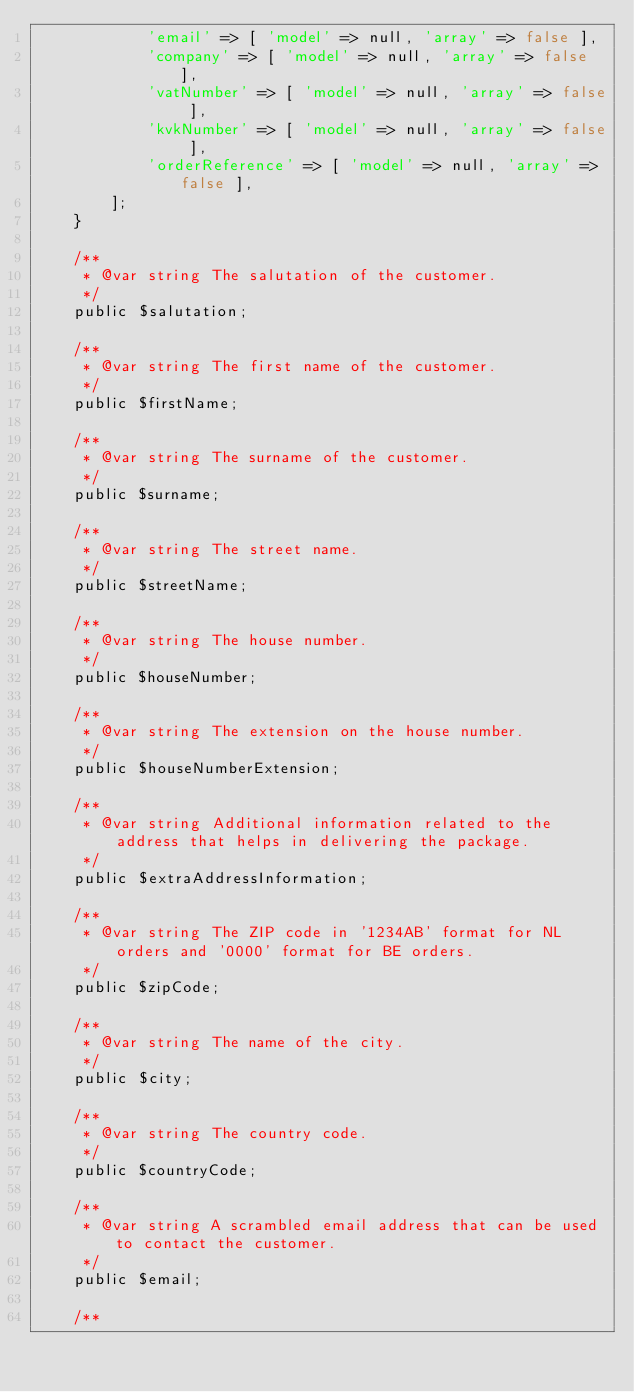Convert code to text. <code><loc_0><loc_0><loc_500><loc_500><_PHP_>            'email' => [ 'model' => null, 'array' => false ],
            'company' => [ 'model' => null, 'array' => false ],
            'vatNumber' => [ 'model' => null, 'array' => false ],
            'kvkNumber' => [ 'model' => null, 'array' => false ],
            'orderReference' => [ 'model' => null, 'array' => false ],
        ];
    }

    /**
     * @var string The salutation of the customer.
     */
    public $salutation;

    /**
     * @var string The first name of the customer.
     */
    public $firstName;

    /**
     * @var string The surname of the customer.
     */
    public $surname;

    /**
     * @var string The street name.
     */
    public $streetName;

    /**
     * @var string The house number.
     */
    public $houseNumber;

    /**
     * @var string The extension on the house number.
     */
    public $houseNumberExtension;

    /**
     * @var string Additional information related to the address that helps in delivering the package.
     */
    public $extraAddressInformation;

    /**
     * @var string The ZIP code in '1234AB' format for NL orders and '0000' format for BE orders.
     */
    public $zipCode;

    /**
     * @var string The name of the city.
     */
    public $city;

    /**
     * @var string The country code.
     */
    public $countryCode;

    /**
     * @var string A scrambled email address that can be used to contact the customer.
     */
    public $email;

    /**</code> 